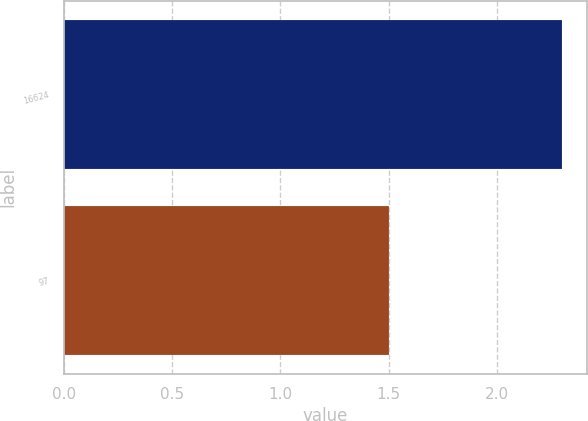Convert chart. <chart><loc_0><loc_0><loc_500><loc_500><bar_chart><fcel>16624<fcel>97<nl><fcel>2.3<fcel>1.5<nl></chart> 